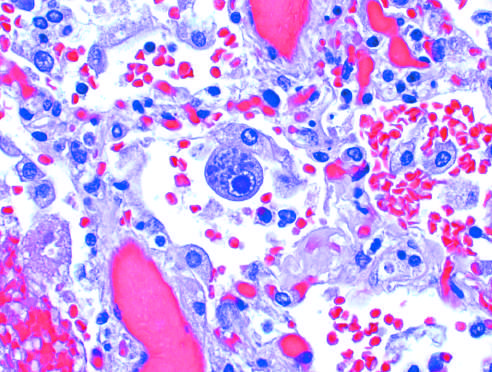re a distinct nuclear inclusion and multiple cytoplasmic inclusions seen in an enlarged cell?
Answer the question using a single word or phrase. Yes 